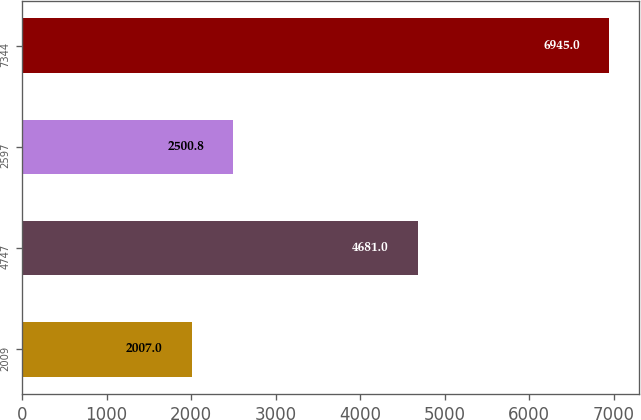<chart> <loc_0><loc_0><loc_500><loc_500><bar_chart><fcel>2009<fcel>4747<fcel>2597<fcel>7344<nl><fcel>2007<fcel>4681<fcel>2500.8<fcel>6945<nl></chart> 